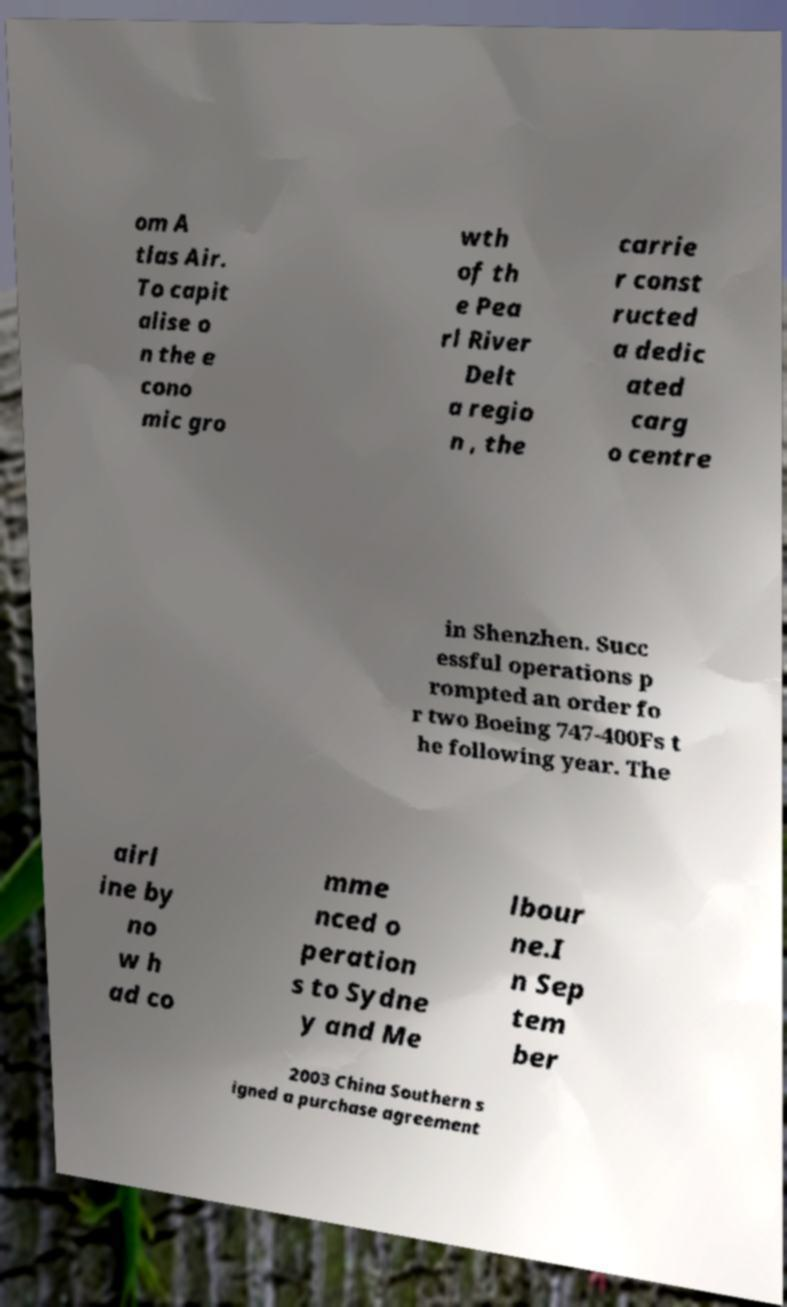Could you assist in decoding the text presented in this image and type it out clearly? om A tlas Air. To capit alise o n the e cono mic gro wth of th e Pea rl River Delt a regio n , the carrie r const ructed a dedic ated carg o centre in Shenzhen. Succ essful operations p rompted an order fo r two Boeing 747-400Fs t he following year. The airl ine by no w h ad co mme nced o peration s to Sydne y and Me lbour ne.I n Sep tem ber 2003 China Southern s igned a purchase agreement 